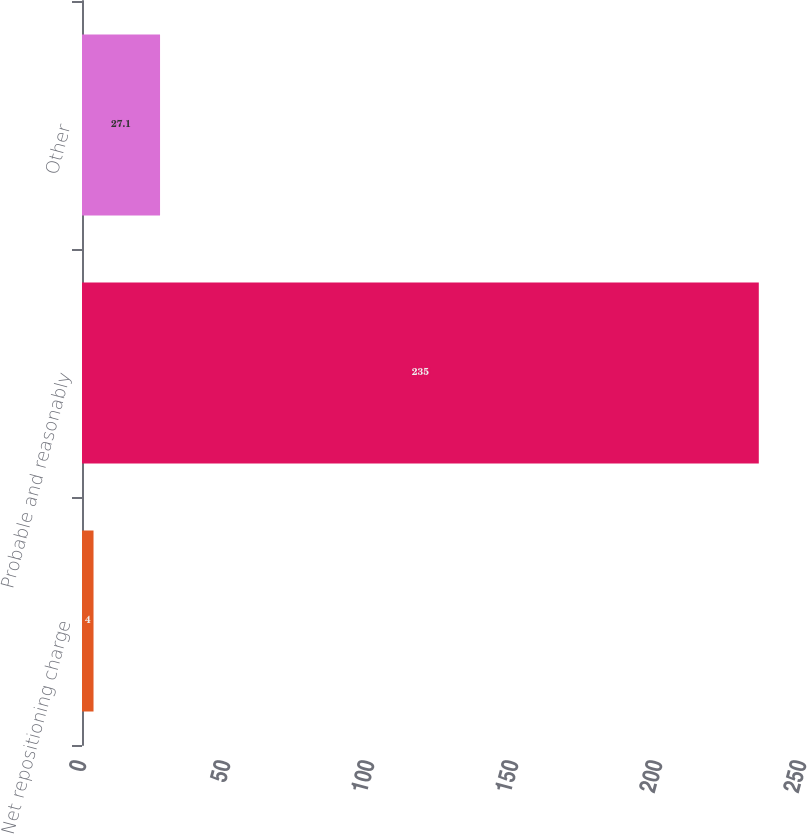Convert chart to OTSL. <chart><loc_0><loc_0><loc_500><loc_500><bar_chart><fcel>Net repositioning charge<fcel>Probable and reasonably<fcel>Other<nl><fcel>4<fcel>235<fcel>27.1<nl></chart> 